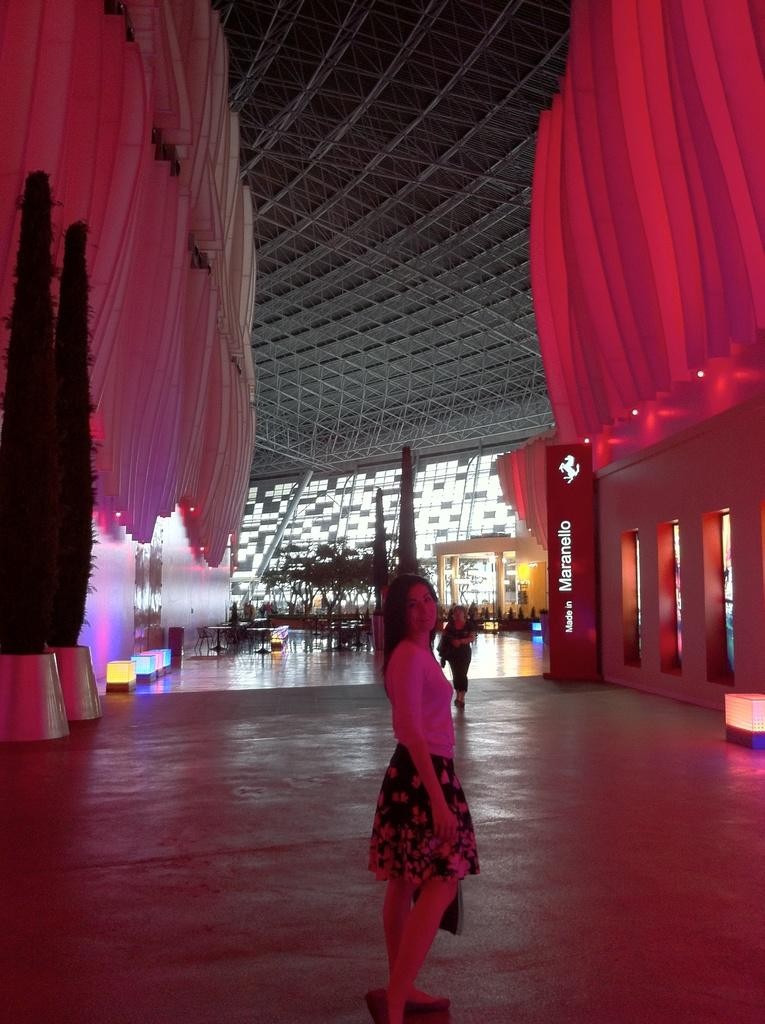What can be seen in the image? There are people standing in the image. Where are the people standing? The people are standing on the floor. What else is visible in the image besides the people? There are trees in a pot and a decorative interior in the background of the image. Can you describe the setting of the decorative interior? The decorative interior is in a building. How does the wind affect the trees on the island in the image? There is no wind, island, or bear present in the image. The image features people standing on the floor, trees in a pot, and a decorative interior in a building. 